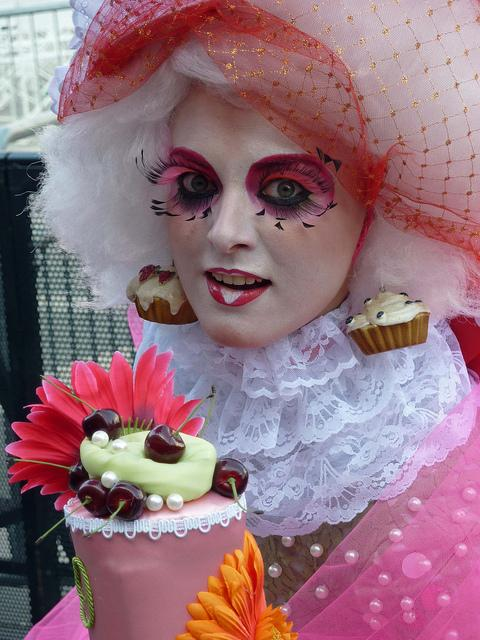What stuff in the photo is edible?

Choices:
A) white pearl
B) muffin
C) flower
D) cherry cherry 